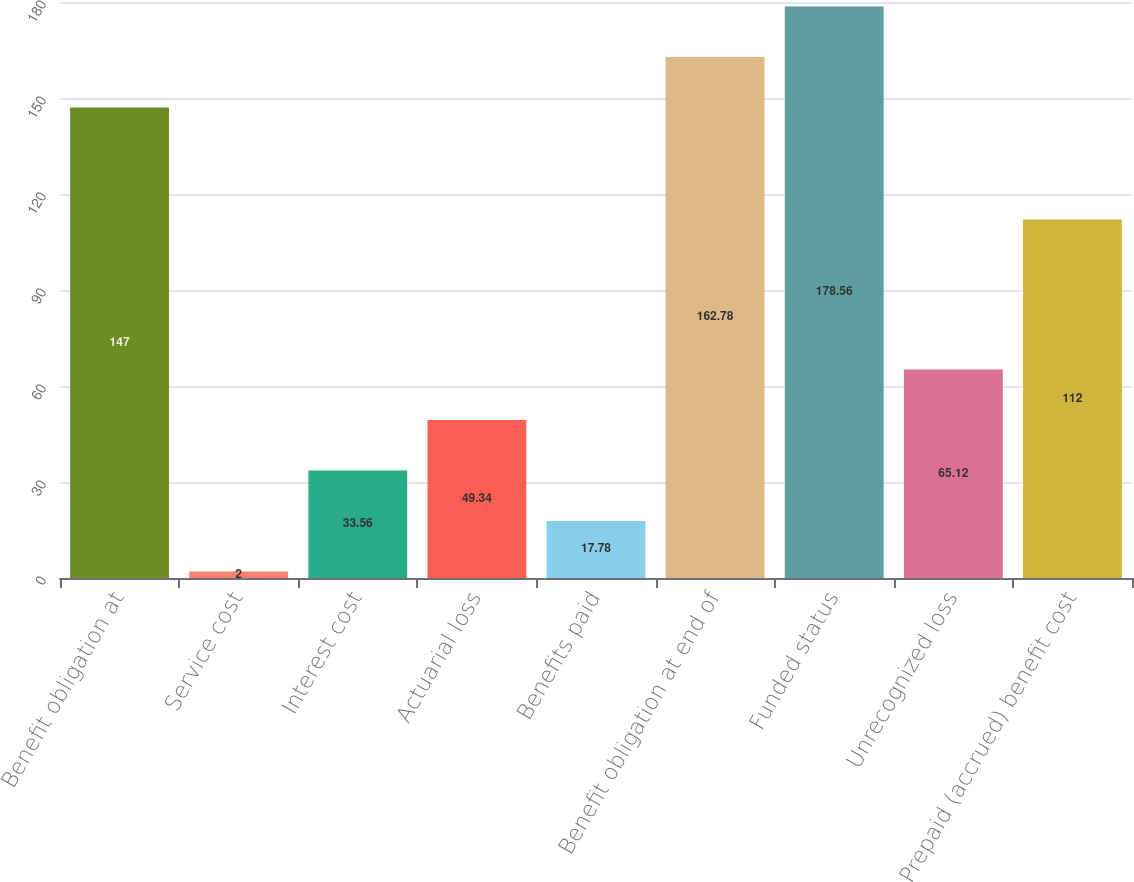Convert chart to OTSL. <chart><loc_0><loc_0><loc_500><loc_500><bar_chart><fcel>Benefit obligation at<fcel>Service cost<fcel>Interest cost<fcel>Actuarial loss<fcel>Benefits paid<fcel>Benefit obligation at end of<fcel>Funded status<fcel>Unrecognized loss<fcel>Prepaid (accrued) benefit cost<nl><fcel>147<fcel>2<fcel>33.56<fcel>49.34<fcel>17.78<fcel>162.78<fcel>178.56<fcel>65.12<fcel>112<nl></chart> 